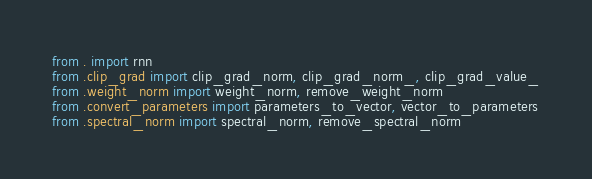Convert code to text. <code><loc_0><loc_0><loc_500><loc_500><_Python_>from . import rnn
from .clip_grad import clip_grad_norm, clip_grad_norm_, clip_grad_value_
from .weight_norm import weight_norm, remove_weight_norm
from .convert_parameters import parameters_to_vector, vector_to_parameters
from .spectral_norm import spectral_norm, remove_spectral_norm
</code> 